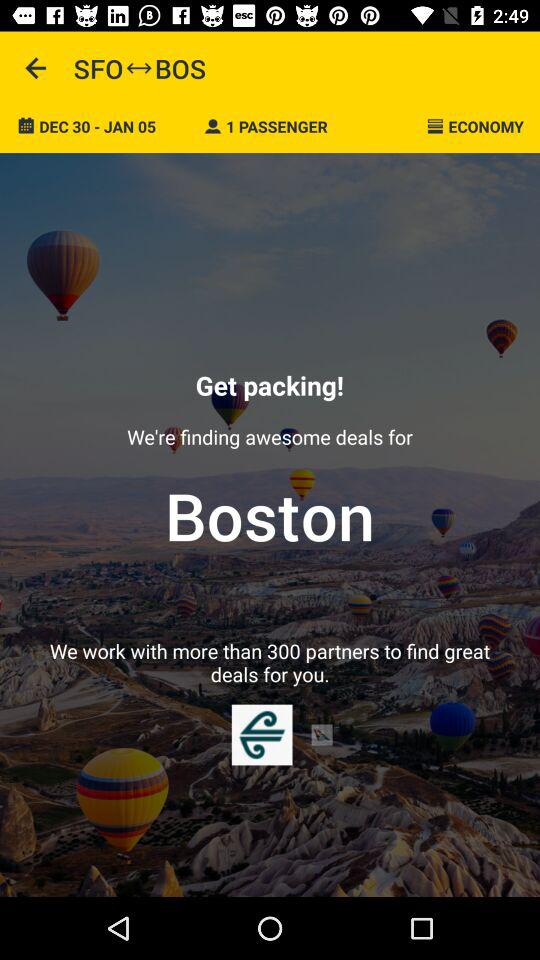Which class is selected? The selected class is economy. 